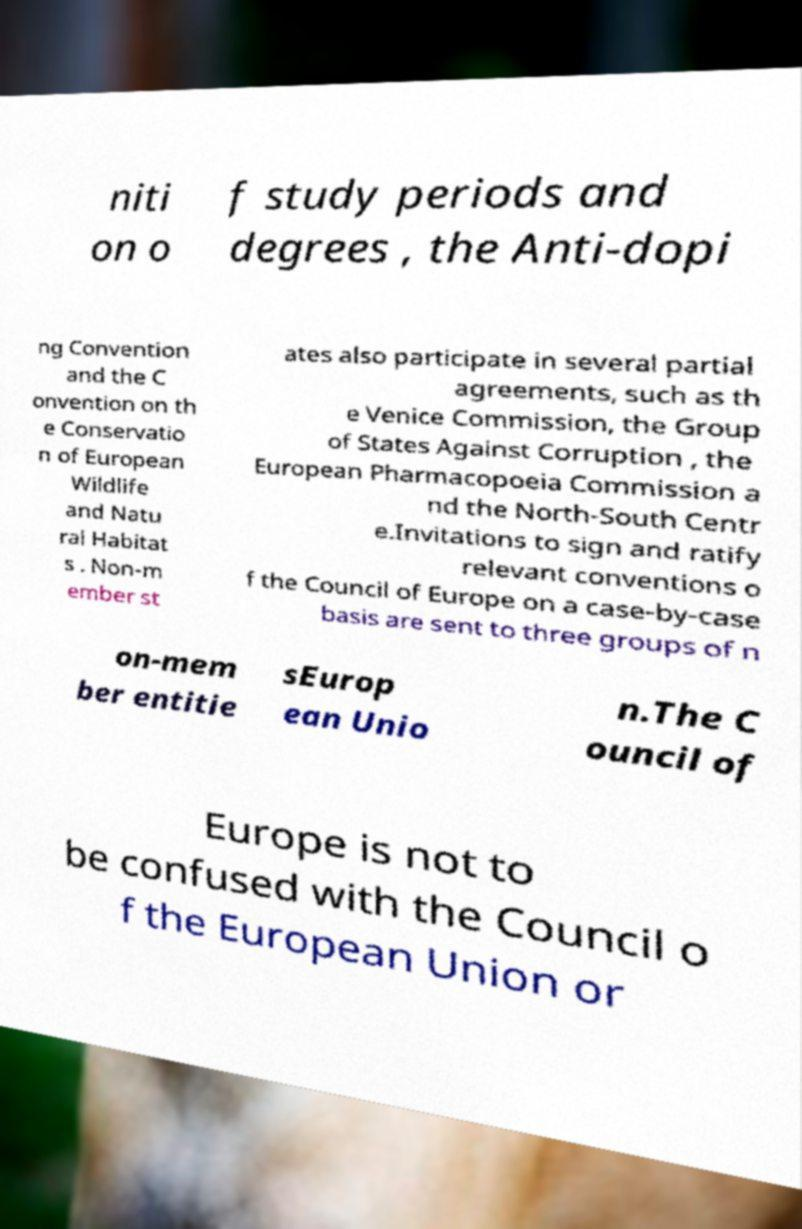I need the written content from this picture converted into text. Can you do that? niti on o f study periods and degrees , the Anti-dopi ng Convention and the C onvention on th e Conservatio n of European Wildlife and Natu ral Habitat s . Non-m ember st ates also participate in several partial agreements, such as th e Venice Commission, the Group of States Against Corruption , the European Pharmacopoeia Commission a nd the North-South Centr e.Invitations to sign and ratify relevant conventions o f the Council of Europe on a case-by-case basis are sent to three groups of n on-mem ber entitie sEurop ean Unio n.The C ouncil of Europe is not to be confused with the Council o f the European Union or 